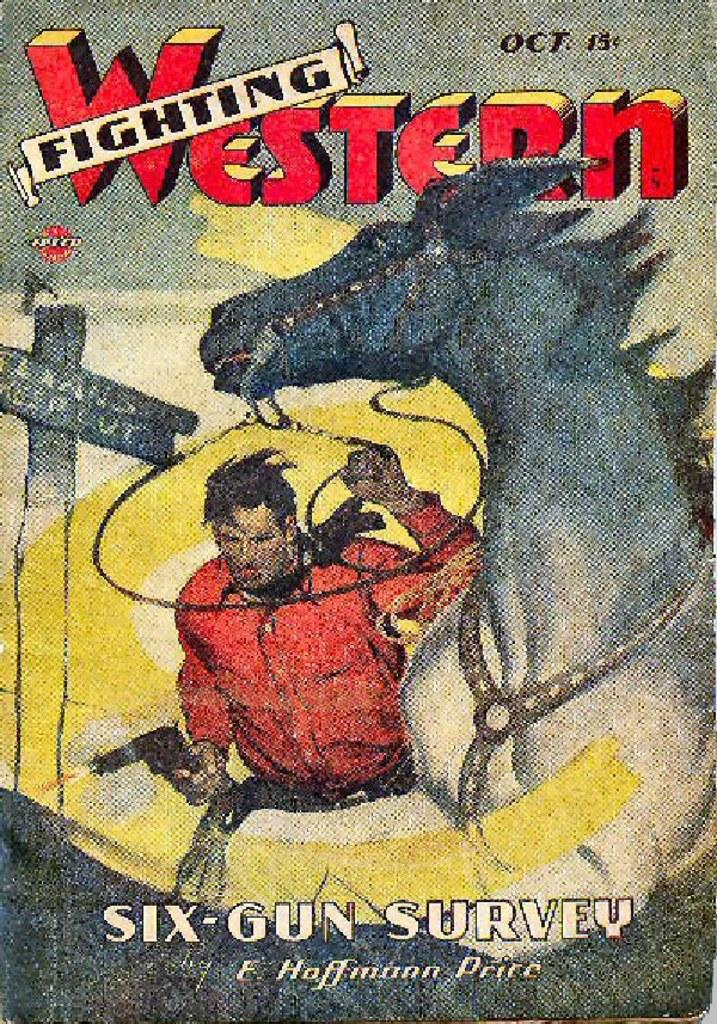<image>
Share a concise interpretation of the image provided. Comic cover that shows a man handling a horse and the name FIghting Western on top. 